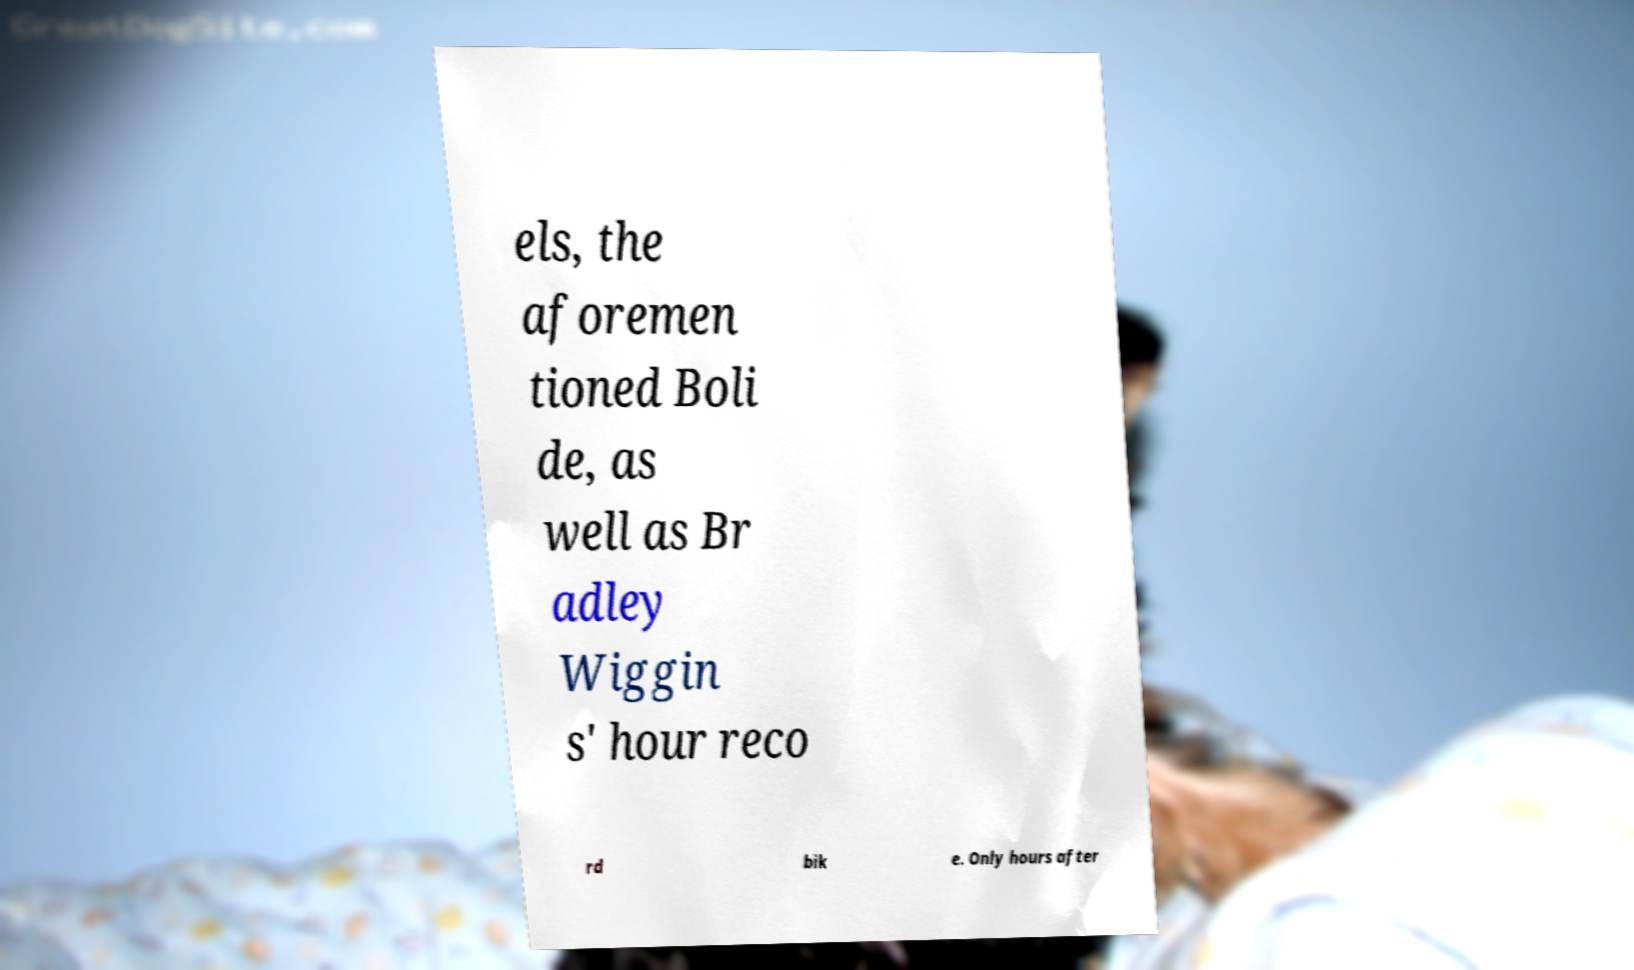Can you read and provide the text displayed in the image?This photo seems to have some interesting text. Can you extract and type it out for me? els, the aforemen tioned Boli de, as well as Br adley Wiggin s' hour reco rd bik e. Only hours after 